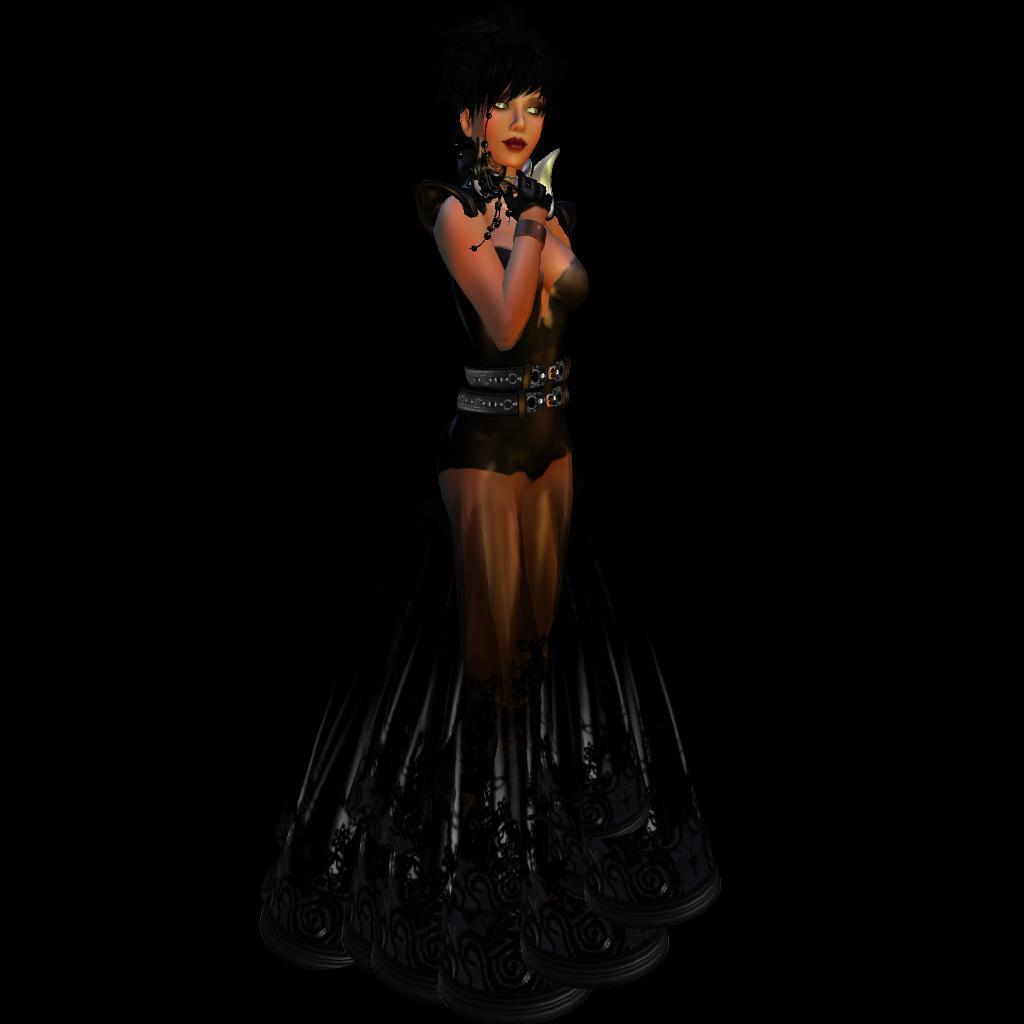What is the main subject of the image? There is a woman standing in the image. What can be seen in the background of the image? The background of the image is black. What type of insurance policy is the woman holding in the image? There is no insurance policy visible in the image; the woman is simply standing. What type of rake is the woman using to order the items in the image? There is no rake or items to order visible in the image; the woman is standing in front of a black background. 